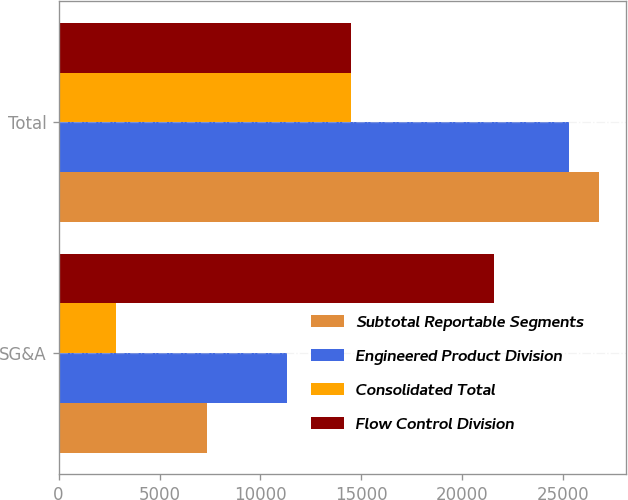Convert chart to OTSL. <chart><loc_0><loc_0><loc_500><loc_500><stacked_bar_chart><ecel><fcel>SG&A<fcel>Total<nl><fcel>Subtotal Reportable Segments<fcel>7376<fcel>26740<nl><fcel>Engineered Product Division<fcel>11311<fcel>25294<nl><fcel>Consolidated Total<fcel>2870<fcel>14470<nl><fcel>Flow Control Division<fcel>21557<fcel>14470<nl></chart> 